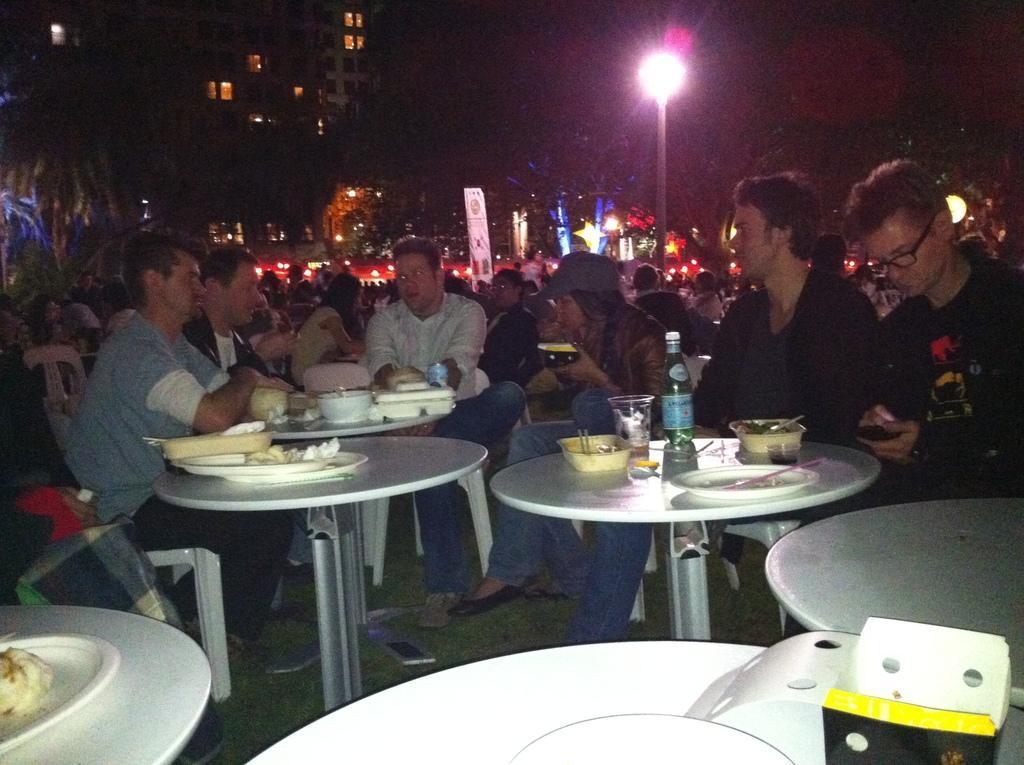How would you summarize this image in a sentence or two? In the image we can see there are people who are sitting on chair and in front of them there is table on which the food items are kept and a wine bottle and at the back there is building and trees. 